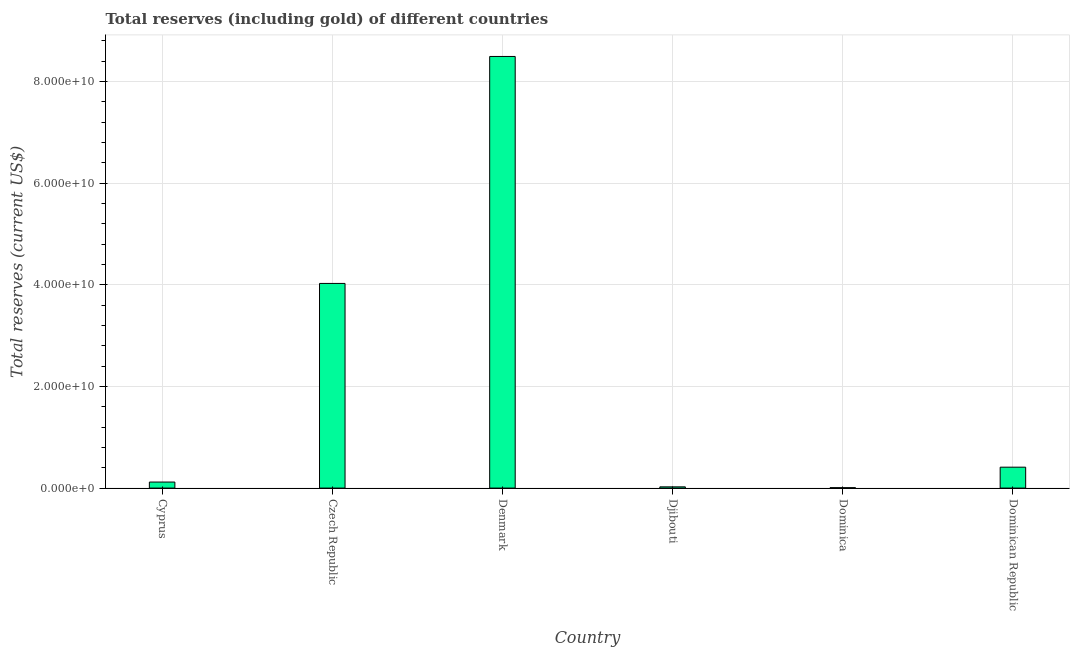Does the graph contain any zero values?
Offer a very short reply. No. Does the graph contain grids?
Keep it short and to the point. Yes. What is the title of the graph?
Make the answer very short. Total reserves (including gold) of different countries. What is the label or title of the Y-axis?
Offer a terse response. Total reserves (current US$). What is the total reserves (including gold) in Dominican Republic?
Make the answer very short. 4.11e+09. Across all countries, what is the maximum total reserves (including gold)?
Give a very brief answer. 8.50e+1. Across all countries, what is the minimum total reserves (including gold)?
Offer a terse response. 8.11e+07. In which country was the total reserves (including gold) maximum?
Offer a terse response. Denmark. In which country was the total reserves (including gold) minimum?
Give a very brief answer. Dominica. What is the sum of the total reserves (including gold)?
Offer a very short reply. 1.31e+11. What is the difference between the total reserves (including gold) in Cyprus and Djibouti?
Provide a short and direct response. 9.43e+08. What is the average total reserves (including gold) per country?
Provide a short and direct response. 2.18e+1. What is the median total reserves (including gold)?
Ensure brevity in your answer.  2.65e+09. What is the ratio of the total reserves (including gold) in Denmark to that in Dominican Republic?
Provide a succinct answer. 20.65. Is the total reserves (including gold) in Cyprus less than that in Czech Republic?
Ensure brevity in your answer.  Yes. What is the difference between the highest and the second highest total reserves (including gold)?
Provide a succinct answer. 4.47e+1. What is the difference between the highest and the lowest total reserves (including gold)?
Your answer should be very brief. 8.49e+1. In how many countries, is the total reserves (including gold) greater than the average total reserves (including gold) taken over all countries?
Make the answer very short. 2. How many bars are there?
Your answer should be very brief. 6. How many countries are there in the graph?
Your response must be concise. 6. What is the difference between two consecutive major ticks on the Y-axis?
Make the answer very short. 2.00e+1. What is the Total reserves (current US$) in Cyprus?
Give a very brief answer. 1.19e+09. What is the Total reserves (current US$) in Czech Republic?
Provide a succinct answer. 4.03e+1. What is the Total reserves (current US$) in Denmark?
Ensure brevity in your answer.  8.50e+1. What is the Total reserves (current US$) of Djibouti?
Your answer should be very brief. 2.44e+08. What is the Total reserves (current US$) of Dominica?
Provide a succinct answer. 8.11e+07. What is the Total reserves (current US$) of Dominican Republic?
Offer a terse response. 4.11e+09. What is the difference between the Total reserves (current US$) in Cyprus and Czech Republic?
Provide a short and direct response. -3.91e+1. What is the difference between the Total reserves (current US$) in Cyprus and Denmark?
Your answer should be very brief. -8.38e+1. What is the difference between the Total reserves (current US$) in Cyprus and Djibouti?
Your answer should be very brief. 9.43e+08. What is the difference between the Total reserves (current US$) in Cyprus and Dominica?
Your answer should be very brief. 1.11e+09. What is the difference between the Total reserves (current US$) in Cyprus and Dominican Republic?
Provide a succinct answer. -2.93e+09. What is the difference between the Total reserves (current US$) in Czech Republic and Denmark?
Offer a very short reply. -4.47e+1. What is the difference between the Total reserves (current US$) in Czech Republic and Djibouti?
Keep it short and to the point. 4.00e+1. What is the difference between the Total reserves (current US$) in Czech Republic and Dominica?
Give a very brief answer. 4.02e+1. What is the difference between the Total reserves (current US$) in Czech Republic and Dominican Republic?
Offer a terse response. 3.62e+1. What is the difference between the Total reserves (current US$) in Denmark and Djibouti?
Make the answer very short. 8.47e+1. What is the difference between the Total reserves (current US$) in Denmark and Dominica?
Keep it short and to the point. 8.49e+1. What is the difference between the Total reserves (current US$) in Denmark and Dominican Republic?
Keep it short and to the point. 8.08e+1. What is the difference between the Total reserves (current US$) in Djibouti and Dominica?
Make the answer very short. 1.63e+08. What is the difference between the Total reserves (current US$) in Djibouti and Dominican Republic?
Offer a terse response. -3.87e+09. What is the difference between the Total reserves (current US$) in Dominica and Dominican Republic?
Offer a terse response. -4.03e+09. What is the ratio of the Total reserves (current US$) in Cyprus to that in Czech Republic?
Offer a very short reply. 0.03. What is the ratio of the Total reserves (current US$) in Cyprus to that in Denmark?
Keep it short and to the point. 0.01. What is the ratio of the Total reserves (current US$) in Cyprus to that in Djibouti?
Your response must be concise. 4.86. What is the ratio of the Total reserves (current US$) in Cyprus to that in Dominica?
Offer a very short reply. 14.63. What is the ratio of the Total reserves (current US$) in Cyprus to that in Dominican Republic?
Your answer should be compact. 0.29. What is the ratio of the Total reserves (current US$) in Czech Republic to that in Denmark?
Give a very brief answer. 0.47. What is the ratio of the Total reserves (current US$) in Czech Republic to that in Djibouti?
Your answer should be compact. 165.02. What is the ratio of the Total reserves (current US$) in Czech Republic to that in Dominica?
Make the answer very short. 496.58. What is the ratio of the Total reserves (current US$) in Czech Republic to that in Dominican Republic?
Give a very brief answer. 9.79. What is the ratio of the Total reserves (current US$) in Denmark to that in Djibouti?
Provide a succinct answer. 348.02. What is the ratio of the Total reserves (current US$) in Denmark to that in Dominica?
Ensure brevity in your answer.  1047.27. What is the ratio of the Total reserves (current US$) in Denmark to that in Dominican Republic?
Offer a very short reply. 20.65. What is the ratio of the Total reserves (current US$) in Djibouti to that in Dominica?
Your response must be concise. 3.01. What is the ratio of the Total reserves (current US$) in Djibouti to that in Dominican Republic?
Ensure brevity in your answer.  0.06. 